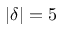<formula> <loc_0><loc_0><loc_500><loc_500>| \delta | = 5</formula> 